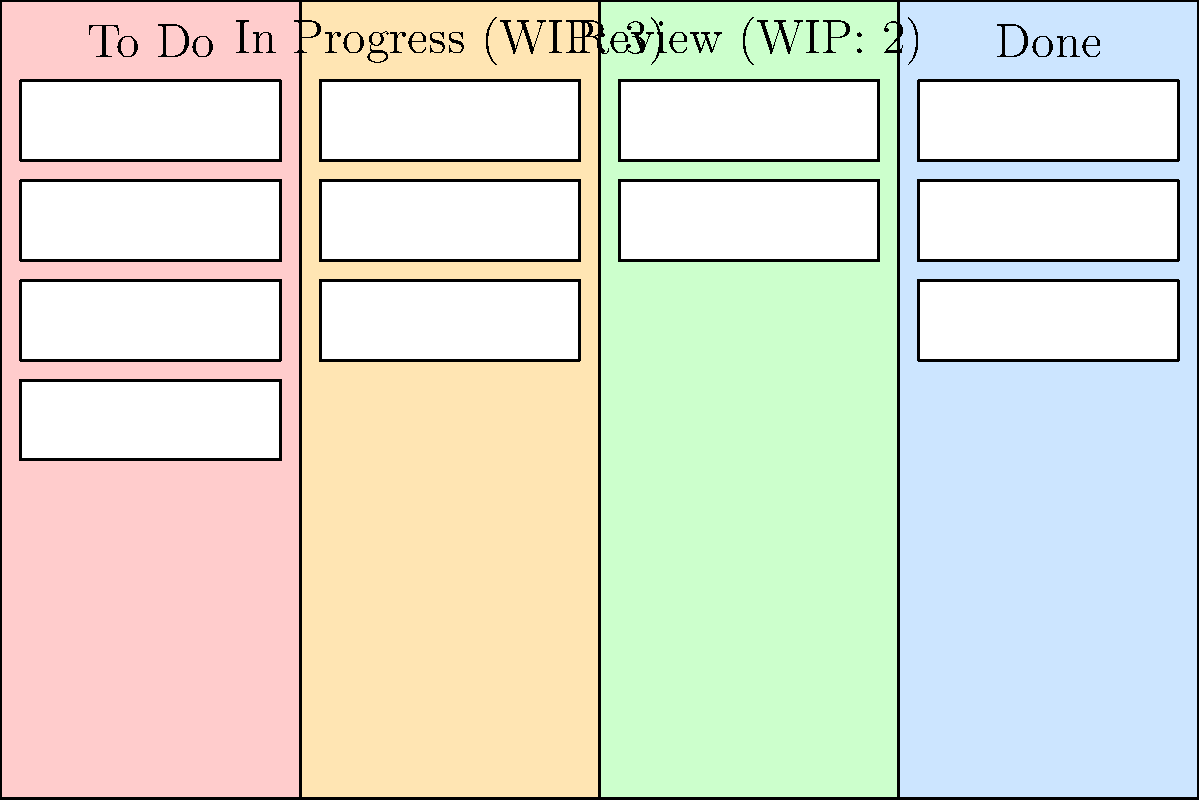Given the Kanban board shown above, which of the following actions would violate the Work-in-Progress (WIP) limits?

A) Moving a task from "To Do" to "In Progress"
B) Moving a task from "In Progress" to "Review"
C) Moving a task from "Review" to "Done"
D) Moving a task from "To Do" to "Review" To answer this question, we need to analyze the current state of the Kanban board and understand the WIP limits for each column:

1. The "To Do" column has no specified WIP limit.
2. The "In Progress" column has a WIP limit of 3, and currently has 3 tasks.
3. The "Review" column has a WIP limit of 2, and currently has 2 tasks.
4. The "Done" column has no specified WIP limit.

Now, let's examine each option:

A) Moving a task from "To Do" to "In Progress" would increase the number of tasks in "In Progress" to 4, which exceeds the WIP limit of 3.

B) Moving a task from "In Progress" to "Review" would not violate any WIP limits. It would reduce the "In Progress" tasks to 2 and increase "Review" tasks to 3, which is within the limit.

C) Moving a task from "Review" to "Done" would not violate any WIP limits. It would reduce the "Review" tasks to 1, which is below the limit, and "Done" has no specified limit.

D) Moving a task from "To Do" to "Review" would increase the number of tasks in "Review" to 3, which exceeds the WIP limit of 2.

Therefore, options A and D would violate the WIP limits.
Answer: A and D 